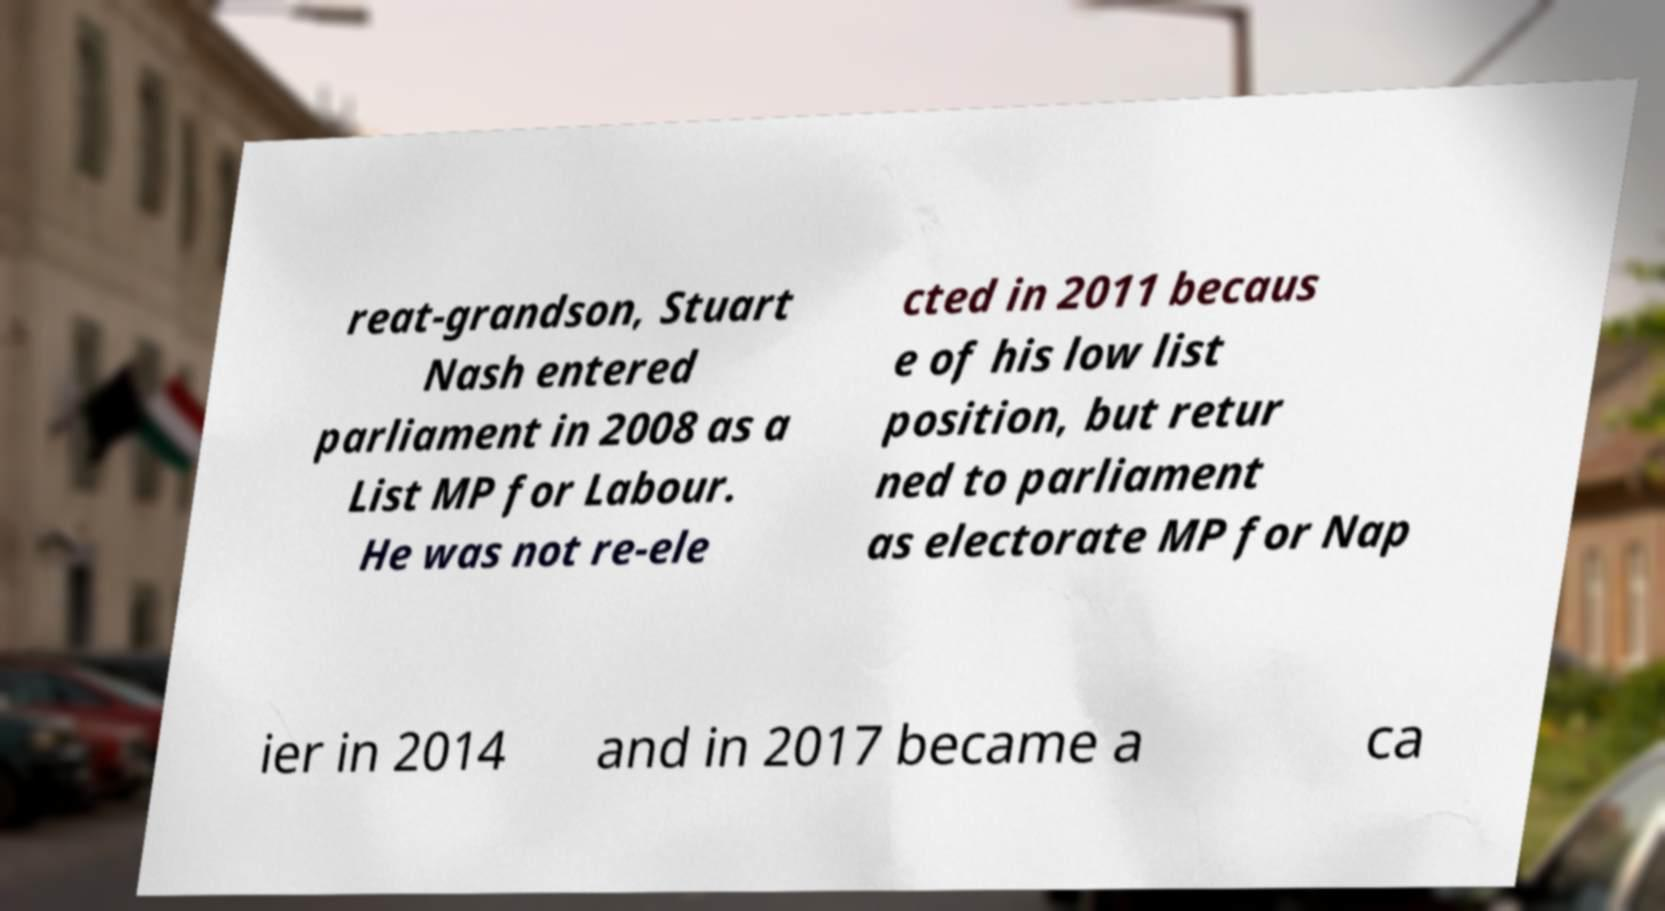There's text embedded in this image that I need extracted. Can you transcribe it verbatim? reat-grandson, Stuart Nash entered parliament in 2008 as a List MP for Labour. He was not re-ele cted in 2011 becaus e of his low list position, but retur ned to parliament as electorate MP for Nap ier in 2014 and in 2017 became a ca 